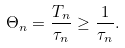Convert formula to latex. <formula><loc_0><loc_0><loc_500><loc_500>\Theta _ { n } = \frac { T _ { n } } { \tau _ { n } } \geq \frac { 1 } { \tau _ { n } } .</formula> 